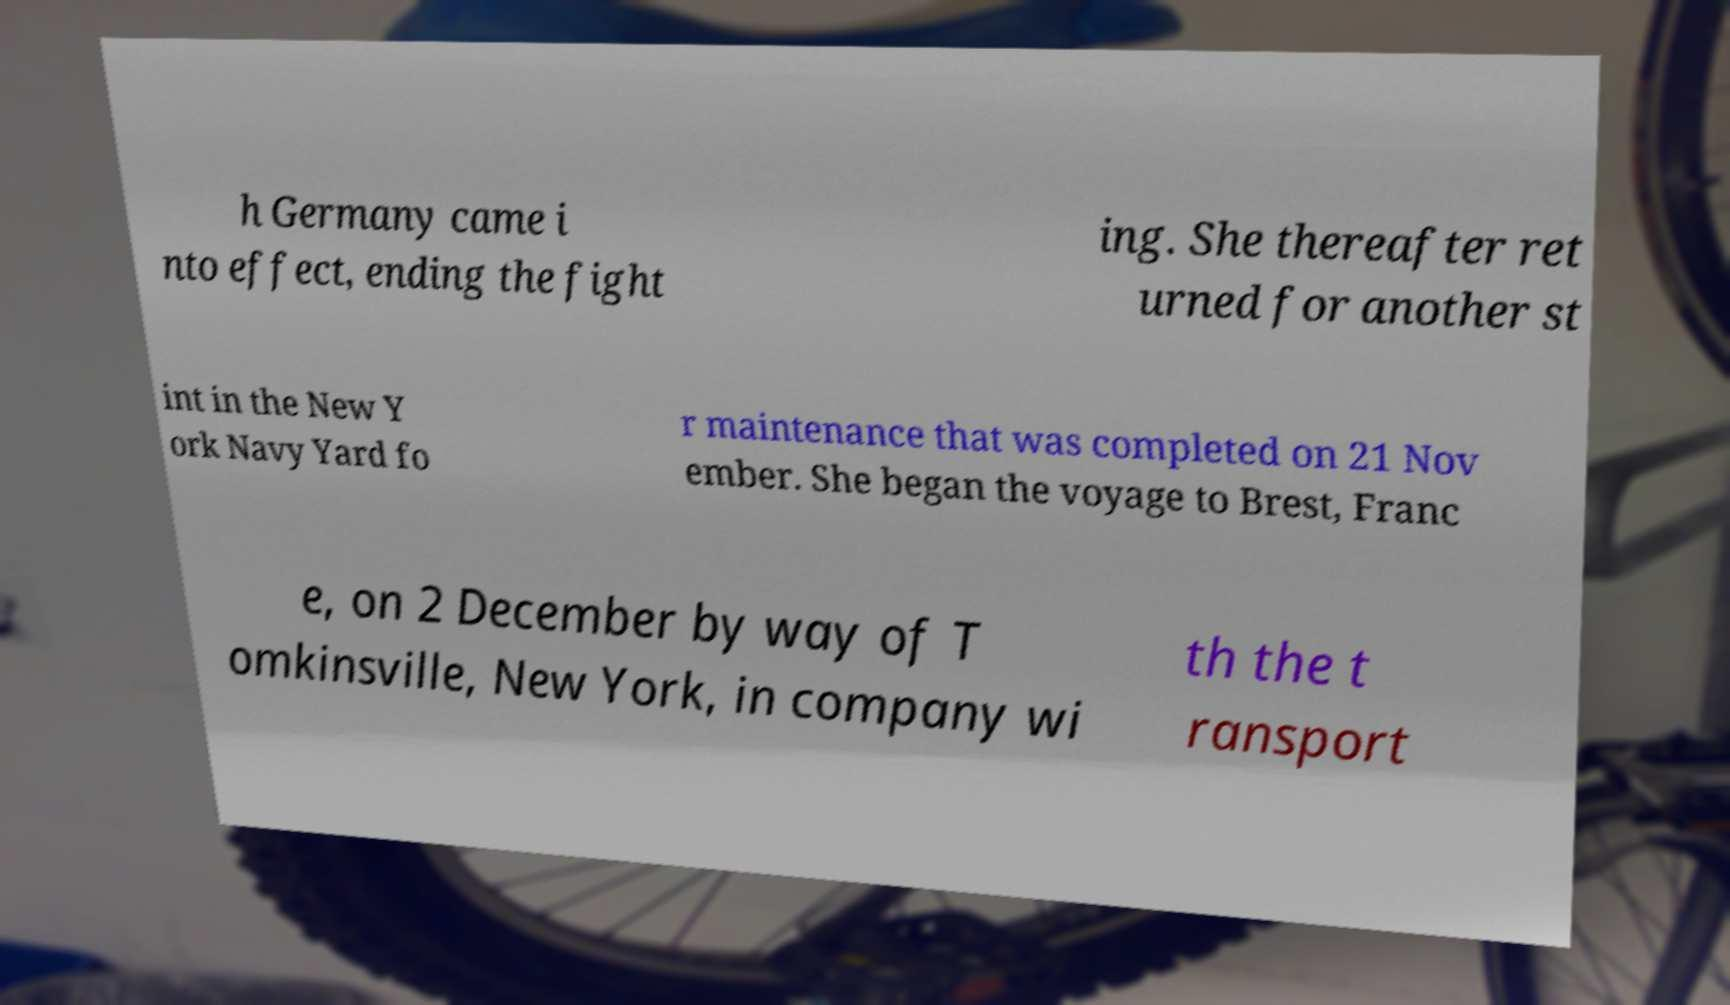Please read and relay the text visible in this image. What does it say? h Germany came i nto effect, ending the fight ing. She thereafter ret urned for another st int in the New Y ork Navy Yard fo r maintenance that was completed on 21 Nov ember. She began the voyage to Brest, Franc e, on 2 December by way of T omkinsville, New York, in company wi th the t ransport 